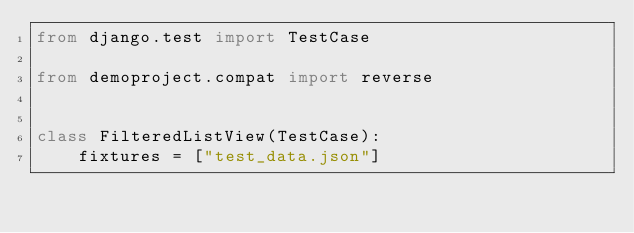Convert code to text. <code><loc_0><loc_0><loc_500><loc_500><_Python_>from django.test import TestCase

from demoproject.compat import reverse


class FilteredListView(TestCase):
    fixtures = ["test_data.json"]
</code> 